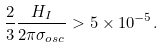Convert formula to latex. <formula><loc_0><loc_0><loc_500><loc_500>\frac { 2 } { 3 } \frac { H _ { I } } { 2 \pi \sigma _ { o s c } } > 5 \times 1 0 ^ { - 5 } .</formula> 